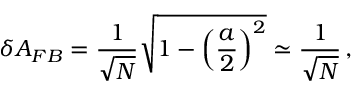<formula> <loc_0><loc_0><loc_500><loc_500>\delta A _ { F B } = \frac { 1 } { \sqrt { N } } \sqrt { 1 - \left ( \frac { a } { 2 } \right ) ^ { 2 } } \simeq \frac { 1 } { \sqrt { N } } \, ,</formula> 